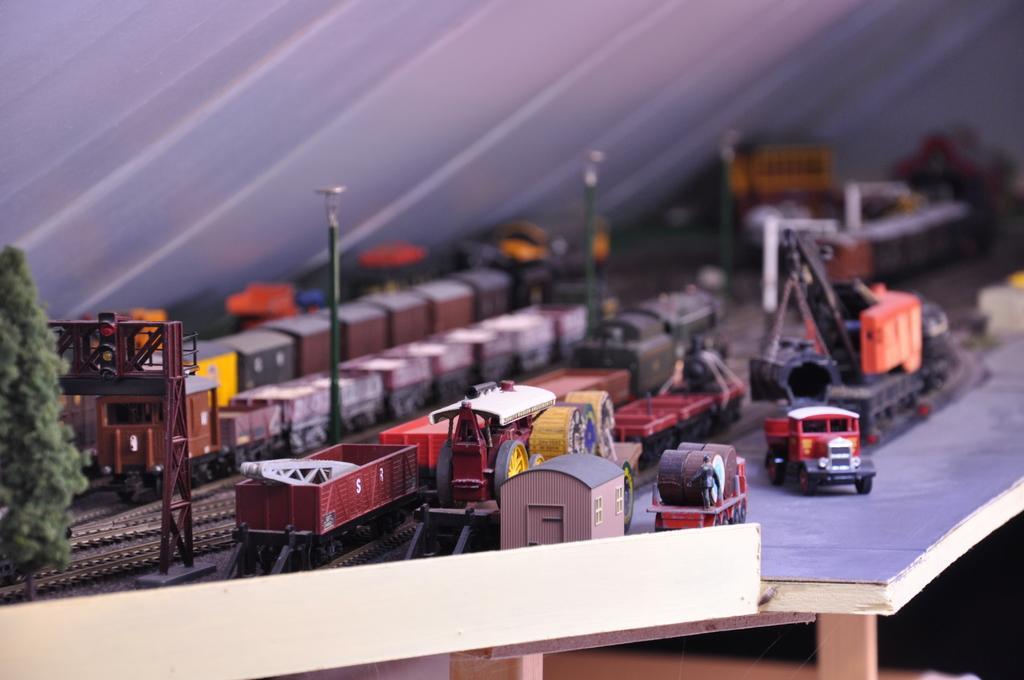How would you summarize this image in a sentence or two? In the image there are toy trains,vehicles,trucks,trees on a table. 